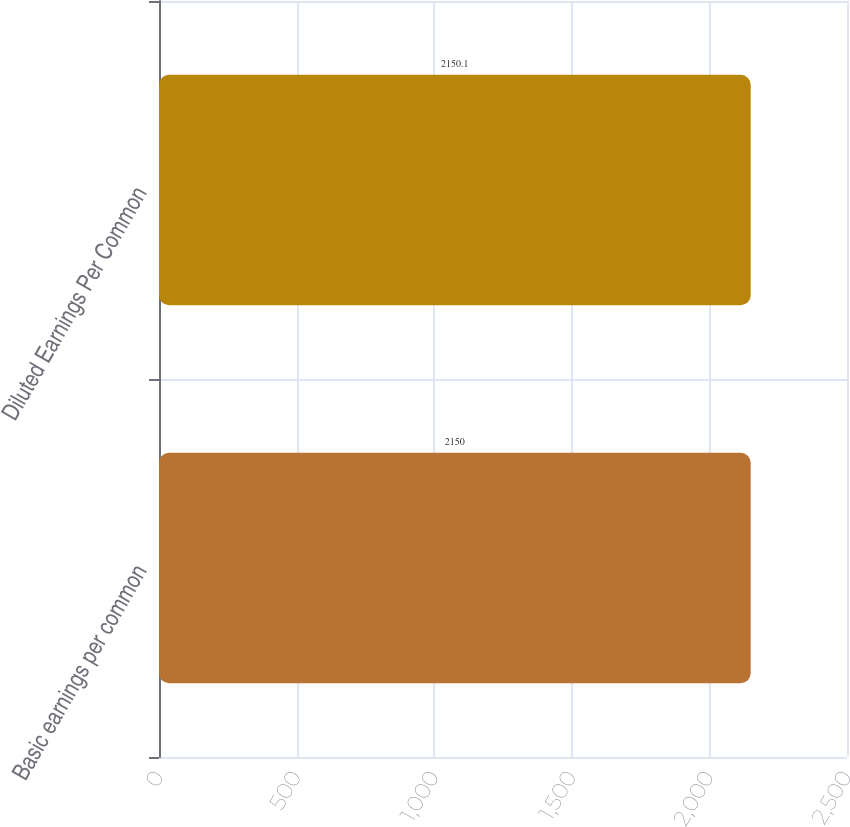Convert chart to OTSL. <chart><loc_0><loc_0><loc_500><loc_500><bar_chart><fcel>Basic earnings per common<fcel>Diluted Earnings Per Common<nl><fcel>2150<fcel>2150.1<nl></chart> 